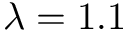Convert formula to latex. <formula><loc_0><loc_0><loc_500><loc_500>\lambda = 1 . 1</formula> 